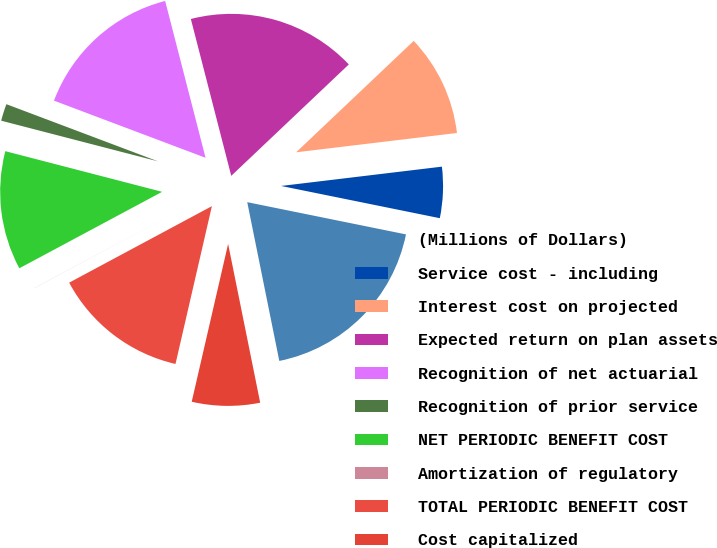<chart> <loc_0><loc_0><loc_500><loc_500><pie_chart><fcel>(Millions of Dollars)<fcel>Service cost - including<fcel>Interest cost on projected<fcel>Expected return on plan assets<fcel>Recognition of net actuarial<fcel>Recognition of prior service<fcel>NET PERIODIC BENEFIT COST<fcel>Amortization of regulatory<fcel>TOTAL PERIODIC BENEFIT COST<fcel>Cost capitalized<nl><fcel>18.64%<fcel>5.09%<fcel>10.17%<fcel>16.94%<fcel>15.25%<fcel>1.7%<fcel>11.86%<fcel>0.01%<fcel>13.56%<fcel>6.78%<nl></chart> 